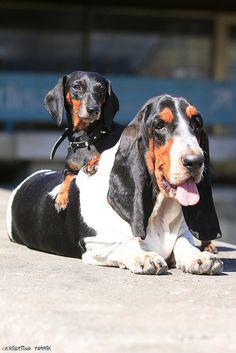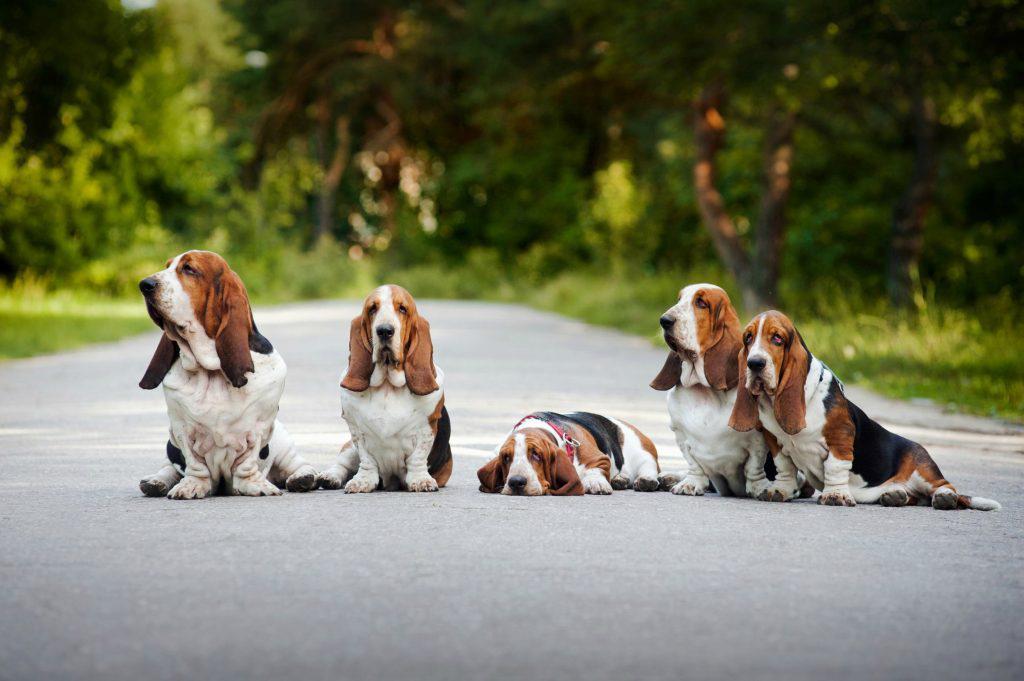The first image is the image on the left, the second image is the image on the right. Evaluate the accuracy of this statement regarding the images: "There are dogs running on pavement.". Is it true? Answer yes or no. No. 